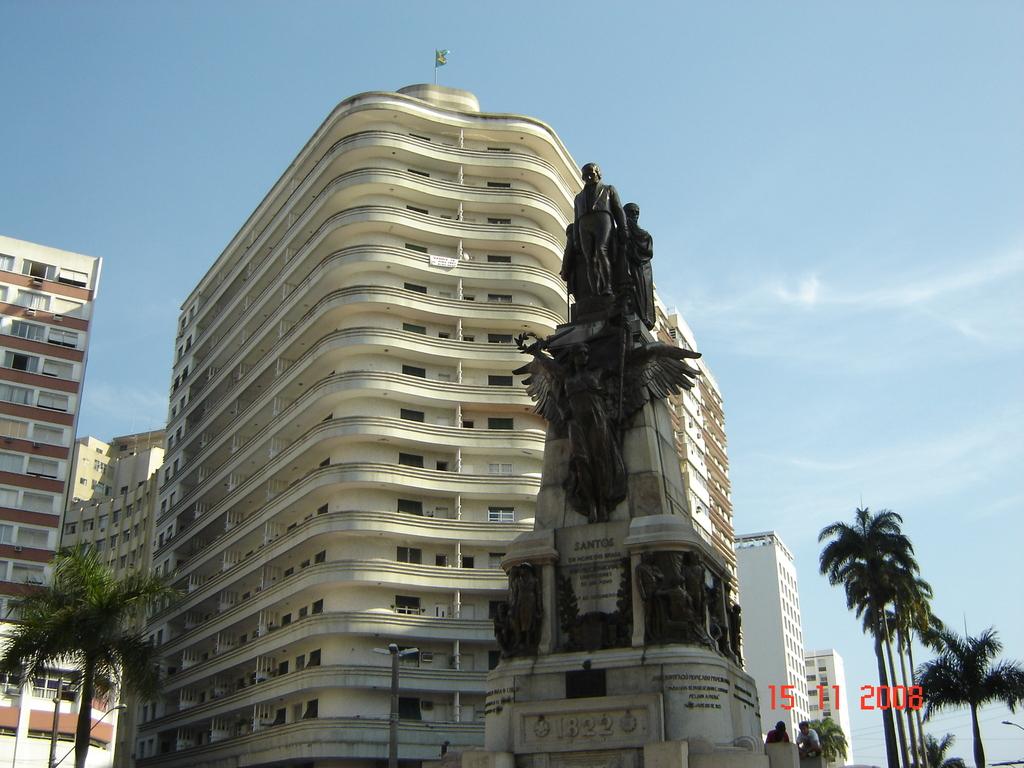What year does the statue say?
Your answer should be very brief. 1822. 